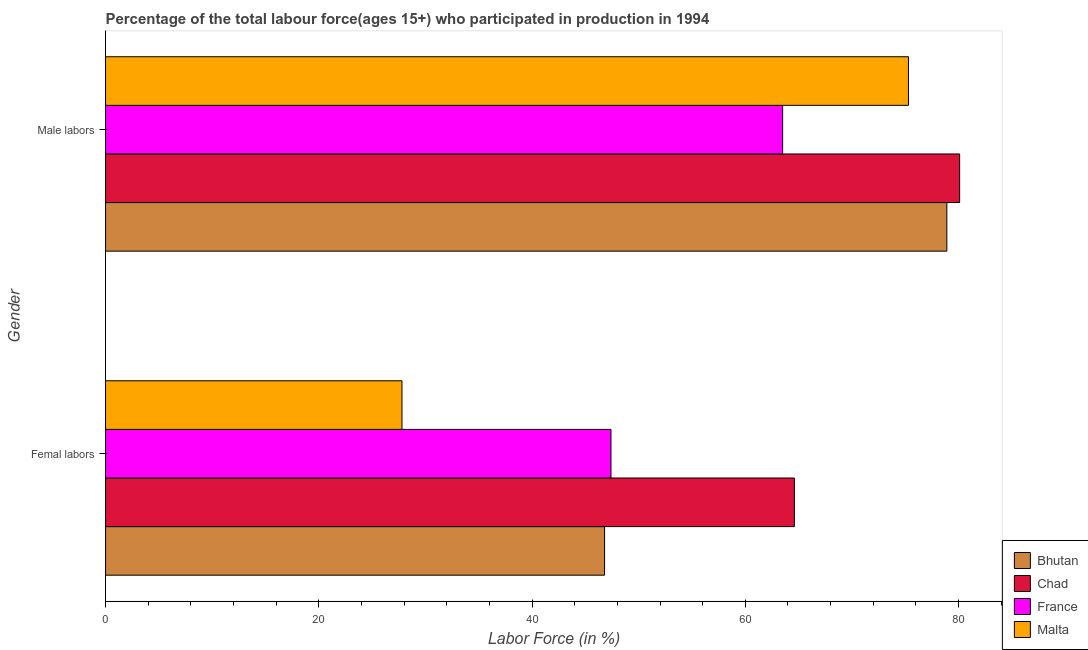How many groups of bars are there?
Keep it short and to the point. 2. How many bars are there on the 1st tick from the top?
Offer a terse response. 4. What is the label of the 2nd group of bars from the top?
Offer a terse response. Femal labors. What is the percentage of female labor force in France?
Your answer should be compact. 47.4. Across all countries, what is the maximum percentage of male labour force?
Keep it short and to the point. 80.1. Across all countries, what is the minimum percentage of female labor force?
Your response must be concise. 27.8. In which country was the percentage of female labor force maximum?
Keep it short and to the point. Chad. In which country was the percentage of female labor force minimum?
Make the answer very short. Malta. What is the total percentage of female labor force in the graph?
Your response must be concise. 186.6. What is the difference between the percentage of male labour force in France and that in Bhutan?
Provide a succinct answer. -15.4. What is the difference between the percentage of male labour force in Malta and the percentage of female labor force in Chad?
Offer a terse response. 10.7. What is the average percentage of male labour force per country?
Ensure brevity in your answer.  74.45. What is the difference between the percentage of female labor force and percentage of male labour force in France?
Give a very brief answer. -16.1. In how many countries, is the percentage of male labour force greater than 32 %?
Keep it short and to the point. 4. What is the ratio of the percentage of male labour force in Bhutan to that in France?
Provide a succinct answer. 1.24. Is the percentage of female labor force in Chad less than that in France?
Provide a succinct answer. No. What does the 3rd bar from the top in Femal labors represents?
Give a very brief answer. Chad. Are all the bars in the graph horizontal?
Keep it short and to the point. Yes. How many countries are there in the graph?
Offer a terse response. 4. What is the difference between two consecutive major ticks on the X-axis?
Provide a short and direct response. 20. What is the title of the graph?
Keep it short and to the point. Percentage of the total labour force(ages 15+) who participated in production in 1994. What is the label or title of the X-axis?
Your response must be concise. Labor Force (in %). What is the Labor Force (in %) of Bhutan in Femal labors?
Provide a short and direct response. 46.8. What is the Labor Force (in %) of Chad in Femal labors?
Your response must be concise. 64.6. What is the Labor Force (in %) in France in Femal labors?
Your answer should be very brief. 47.4. What is the Labor Force (in %) in Malta in Femal labors?
Make the answer very short. 27.8. What is the Labor Force (in %) in Bhutan in Male labors?
Make the answer very short. 78.9. What is the Labor Force (in %) in Chad in Male labors?
Ensure brevity in your answer.  80.1. What is the Labor Force (in %) in France in Male labors?
Your response must be concise. 63.5. What is the Labor Force (in %) in Malta in Male labors?
Make the answer very short. 75.3. Across all Gender, what is the maximum Labor Force (in %) of Bhutan?
Your answer should be very brief. 78.9. Across all Gender, what is the maximum Labor Force (in %) in Chad?
Ensure brevity in your answer.  80.1. Across all Gender, what is the maximum Labor Force (in %) in France?
Your answer should be compact. 63.5. Across all Gender, what is the maximum Labor Force (in %) in Malta?
Offer a terse response. 75.3. Across all Gender, what is the minimum Labor Force (in %) of Bhutan?
Your answer should be compact. 46.8. Across all Gender, what is the minimum Labor Force (in %) of Chad?
Provide a short and direct response. 64.6. Across all Gender, what is the minimum Labor Force (in %) of France?
Provide a short and direct response. 47.4. Across all Gender, what is the minimum Labor Force (in %) of Malta?
Provide a short and direct response. 27.8. What is the total Labor Force (in %) of Bhutan in the graph?
Your answer should be very brief. 125.7. What is the total Labor Force (in %) in Chad in the graph?
Keep it short and to the point. 144.7. What is the total Labor Force (in %) in France in the graph?
Ensure brevity in your answer.  110.9. What is the total Labor Force (in %) in Malta in the graph?
Your answer should be very brief. 103.1. What is the difference between the Labor Force (in %) in Bhutan in Femal labors and that in Male labors?
Provide a succinct answer. -32.1. What is the difference between the Labor Force (in %) of Chad in Femal labors and that in Male labors?
Offer a terse response. -15.5. What is the difference between the Labor Force (in %) in France in Femal labors and that in Male labors?
Your response must be concise. -16.1. What is the difference between the Labor Force (in %) of Malta in Femal labors and that in Male labors?
Offer a terse response. -47.5. What is the difference between the Labor Force (in %) in Bhutan in Femal labors and the Labor Force (in %) in Chad in Male labors?
Give a very brief answer. -33.3. What is the difference between the Labor Force (in %) in Bhutan in Femal labors and the Labor Force (in %) in France in Male labors?
Keep it short and to the point. -16.7. What is the difference between the Labor Force (in %) of Bhutan in Femal labors and the Labor Force (in %) of Malta in Male labors?
Make the answer very short. -28.5. What is the difference between the Labor Force (in %) in Chad in Femal labors and the Labor Force (in %) in France in Male labors?
Your response must be concise. 1.1. What is the difference between the Labor Force (in %) in Chad in Femal labors and the Labor Force (in %) in Malta in Male labors?
Provide a short and direct response. -10.7. What is the difference between the Labor Force (in %) of France in Femal labors and the Labor Force (in %) of Malta in Male labors?
Offer a terse response. -27.9. What is the average Labor Force (in %) of Bhutan per Gender?
Your answer should be compact. 62.85. What is the average Labor Force (in %) in Chad per Gender?
Provide a short and direct response. 72.35. What is the average Labor Force (in %) in France per Gender?
Provide a succinct answer. 55.45. What is the average Labor Force (in %) in Malta per Gender?
Provide a short and direct response. 51.55. What is the difference between the Labor Force (in %) in Bhutan and Labor Force (in %) in Chad in Femal labors?
Keep it short and to the point. -17.8. What is the difference between the Labor Force (in %) of Bhutan and Labor Force (in %) of France in Femal labors?
Keep it short and to the point. -0.6. What is the difference between the Labor Force (in %) of Bhutan and Labor Force (in %) of Malta in Femal labors?
Give a very brief answer. 19. What is the difference between the Labor Force (in %) in Chad and Labor Force (in %) in Malta in Femal labors?
Give a very brief answer. 36.8. What is the difference between the Labor Force (in %) in France and Labor Force (in %) in Malta in Femal labors?
Your response must be concise. 19.6. What is the difference between the Labor Force (in %) in Bhutan and Labor Force (in %) in Chad in Male labors?
Offer a very short reply. -1.2. What is the difference between the Labor Force (in %) in Bhutan and Labor Force (in %) in France in Male labors?
Your answer should be very brief. 15.4. What is the difference between the Labor Force (in %) of France and Labor Force (in %) of Malta in Male labors?
Offer a very short reply. -11.8. What is the ratio of the Labor Force (in %) of Bhutan in Femal labors to that in Male labors?
Keep it short and to the point. 0.59. What is the ratio of the Labor Force (in %) in Chad in Femal labors to that in Male labors?
Ensure brevity in your answer.  0.81. What is the ratio of the Labor Force (in %) in France in Femal labors to that in Male labors?
Ensure brevity in your answer.  0.75. What is the ratio of the Labor Force (in %) of Malta in Femal labors to that in Male labors?
Your answer should be compact. 0.37. What is the difference between the highest and the second highest Labor Force (in %) in Bhutan?
Your answer should be very brief. 32.1. What is the difference between the highest and the second highest Labor Force (in %) of Chad?
Provide a short and direct response. 15.5. What is the difference between the highest and the second highest Labor Force (in %) in Malta?
Give a very brief answer. 47.5. What is the difference between the highest and the lowest Labor Force (in %) in Bhutan?
Keep it short and to the point. 32.1. What is the difference between the highest and the lowest Labor Force (in %) in Malta?
Ensure brevity in your answer.  47.5. 